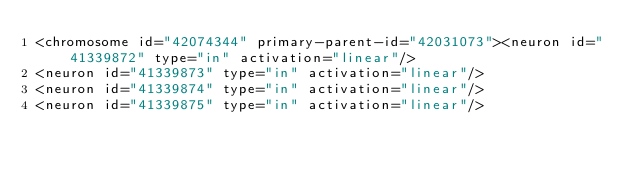Convert code to text. <code><loc_0><loc_0><loc_500><loc_500><_XML_><chromosome id="42074344" primary-parent-id="42031073"><neuron id="41339872" type="in" activation="linear"/>
<neuron id="41339873" type="in" activation="linear"/>
<neuron id="41339874" type="in" activation="linear"/>
<neuron id="41339875" type="in" activation="linear"/></code> 